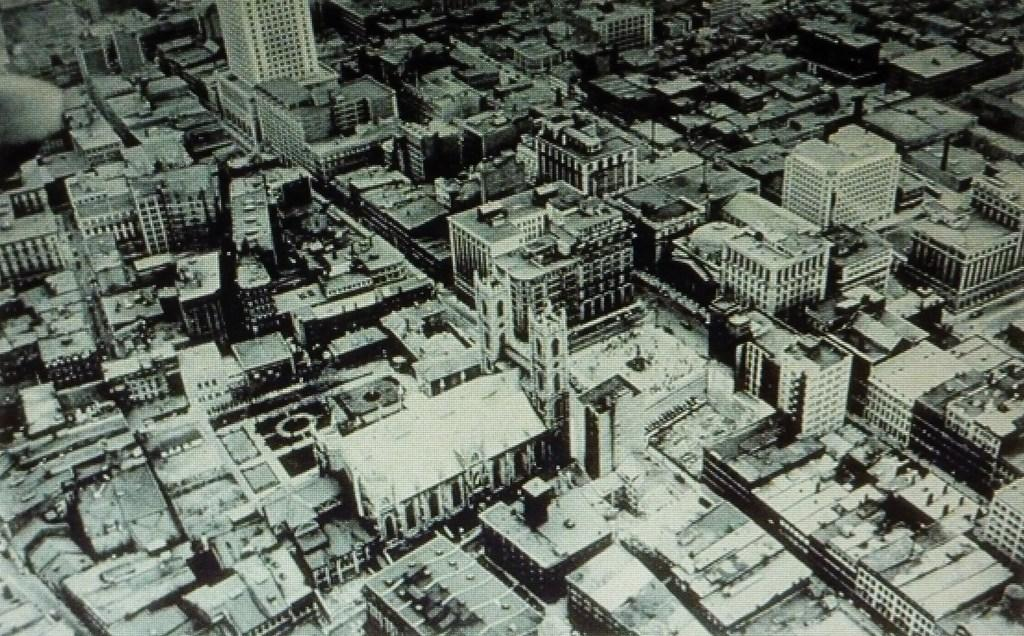What type of structures are present in the image? There are buildings in the image. What color scheme is used in the image? The image is in black and white. What type of calculator can be seen on the roof of the building in the image? There is no calculator present in the image; it only features buildings in black and white. 